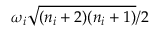<formula> <loc_0><loc_0><loc_500><loc_500>{ \omega _ { i } } \sqrt { ( n _ { i } + 2 ) ( n _ { i } + 1 ) } / 2</formula> 